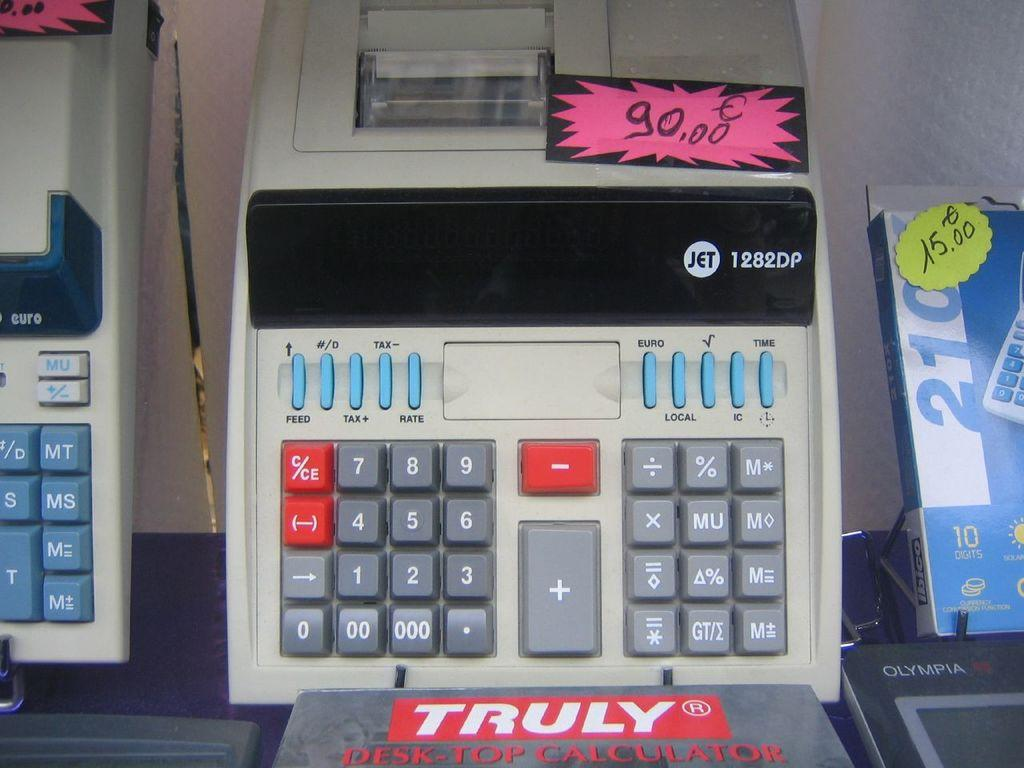Provide a one-sentence caption for the provided image. An adding machine made by Jet has a 90.00 price tag. 